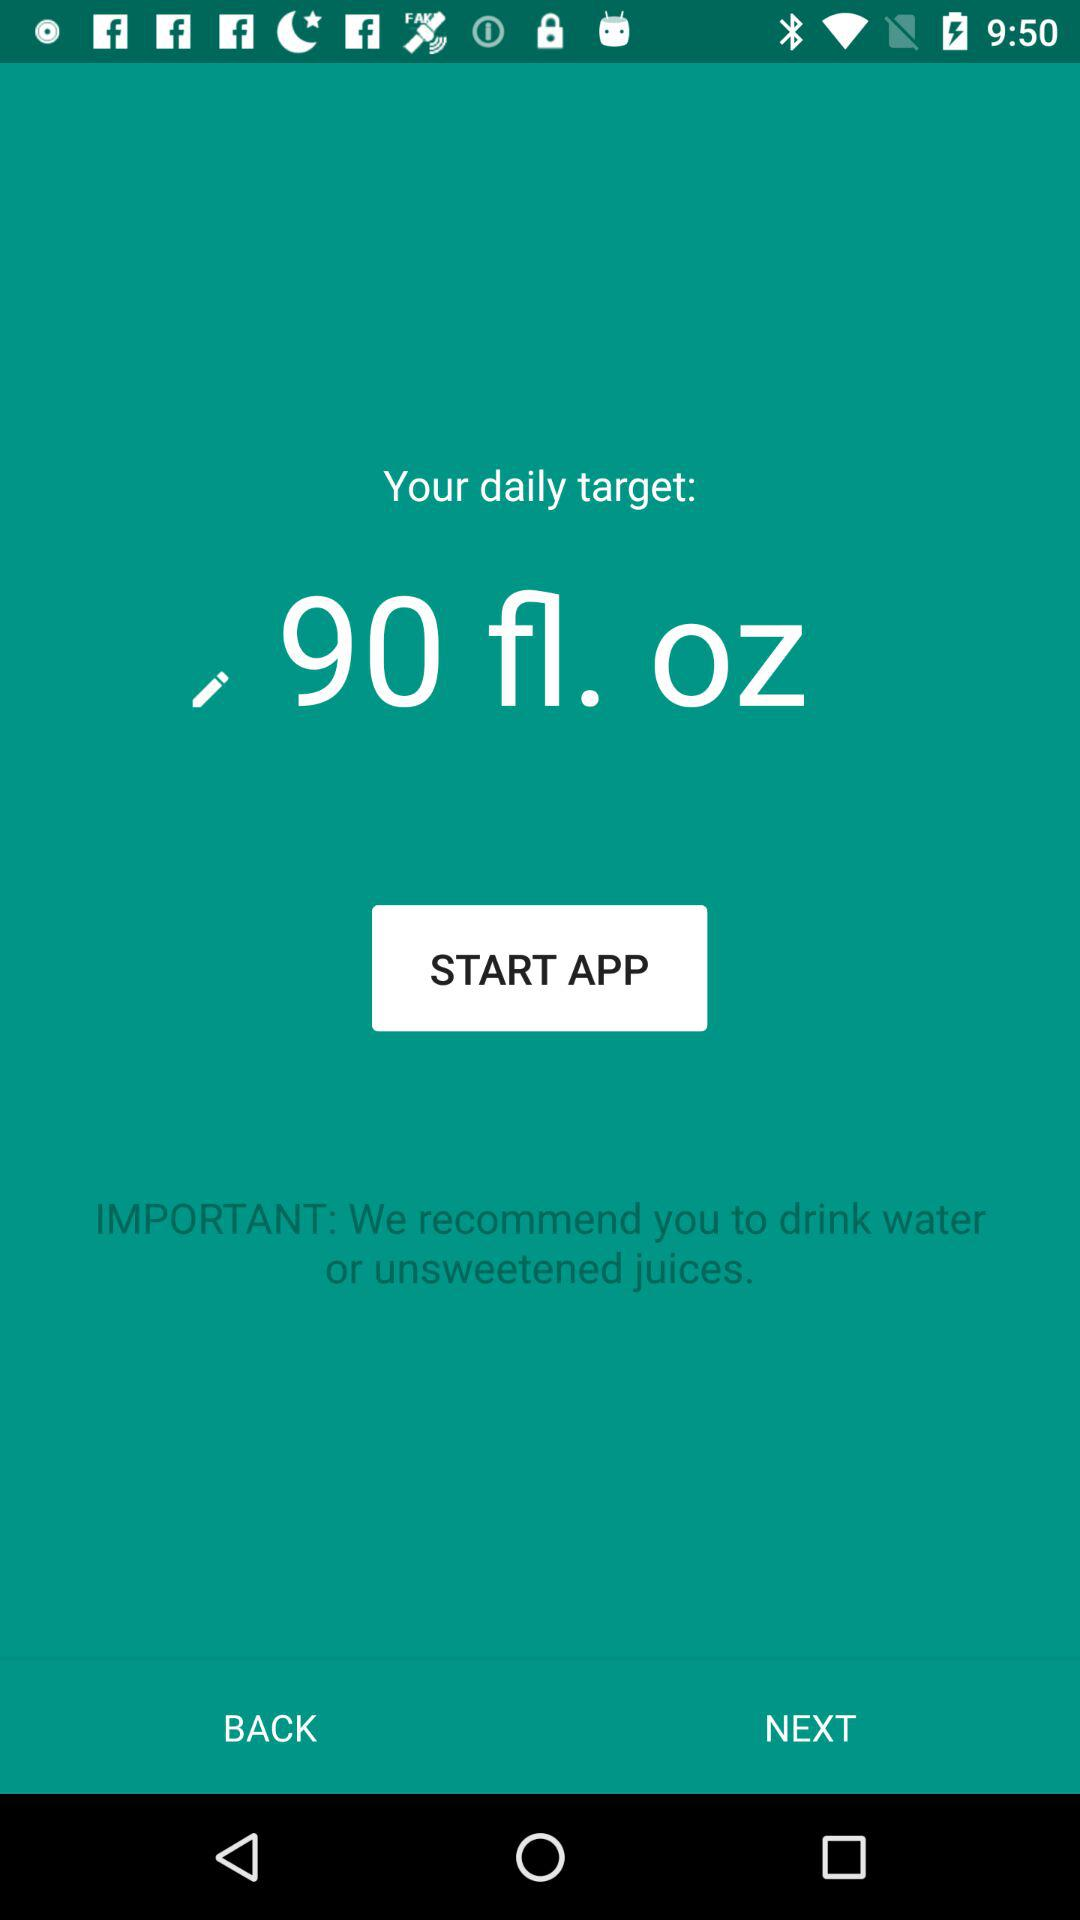What is the important instruction? The important instruction is "We recommend you to drink water or unsweetened juices". 